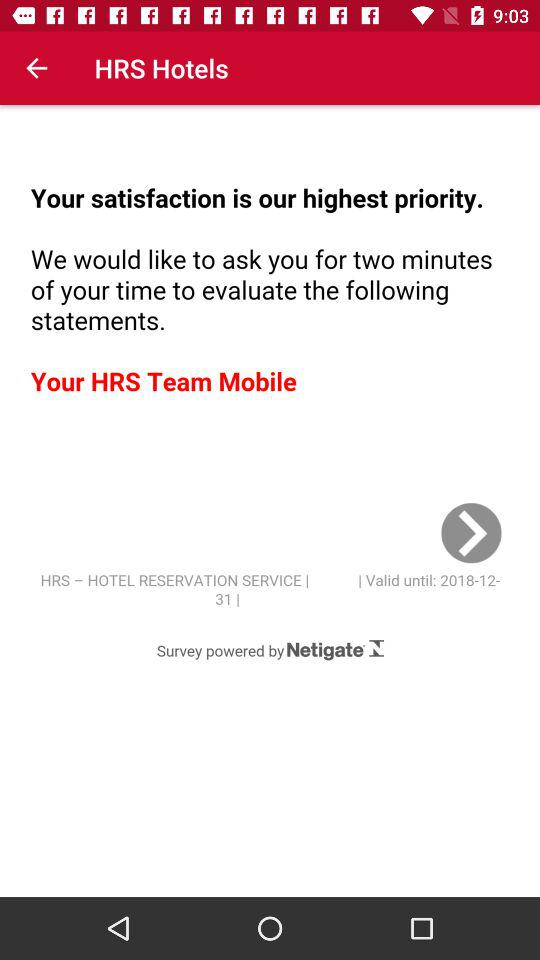What is the valid date of the service? The valid date is 2018-12-31. 